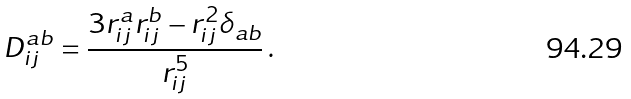Convert formula to latex. <formula><loc_0><loc_0><loc_500><loc_500>D _ { i j } ^ { a b } = \frac { 3 r _ { i j } ^ { a } r _ { i j } ^ { b } - r _ { i j } ^ { 2 } \delta _ { a b } } { r _ { i j } ^ { 5 } } \, .</formula> 